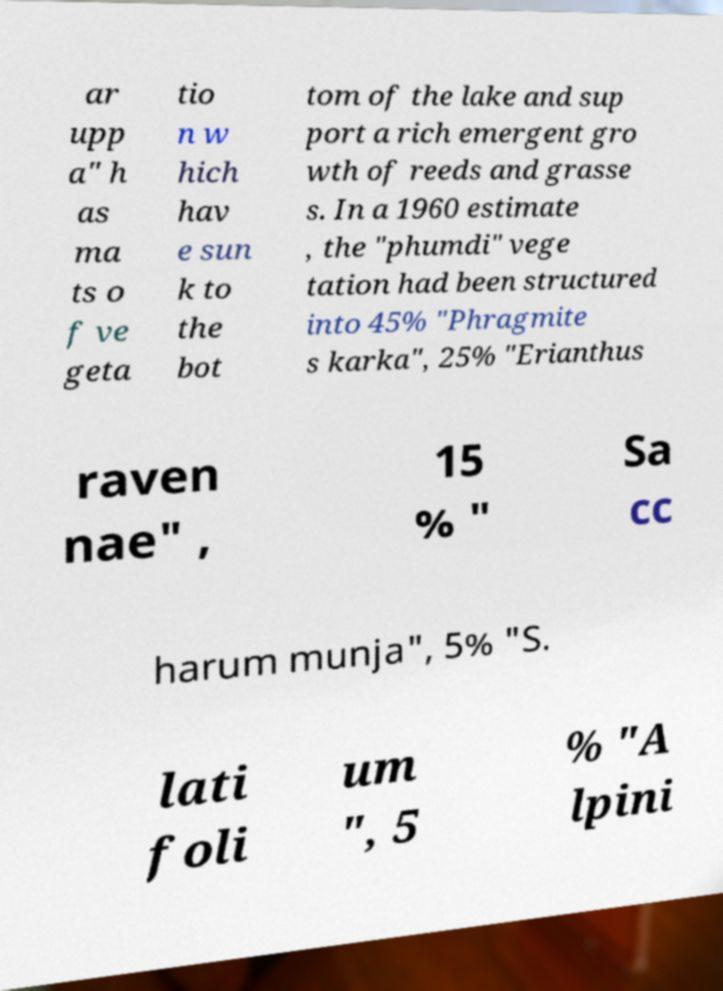Could you assist in decoding the text presented in this image and type it out clearly? ar upp a" h as ma ts o f ve geta tio n w hich hav e sun k to the bot tom of the lake and sup port a rich emergent gro wth of reeds and grasse s. In a 1960 estimate , the "phumdi" vege tation had been structured into 45% "Phragmite s karka", 25% "Erianthus raven nae" , 15 % " Sa cc harum munja", 5% "S. lati foli um ", 5 % "A lpini 